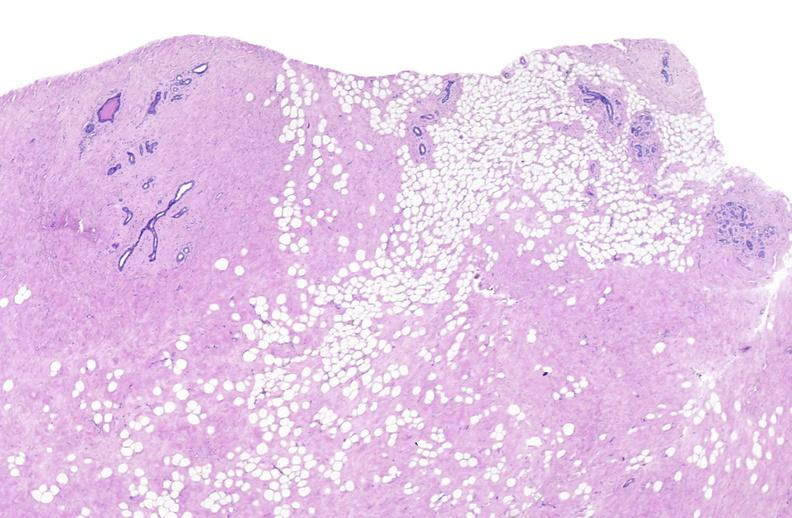does this image show breast, fibroadenoma?
Answer the question using a single word or phrase. Yes 